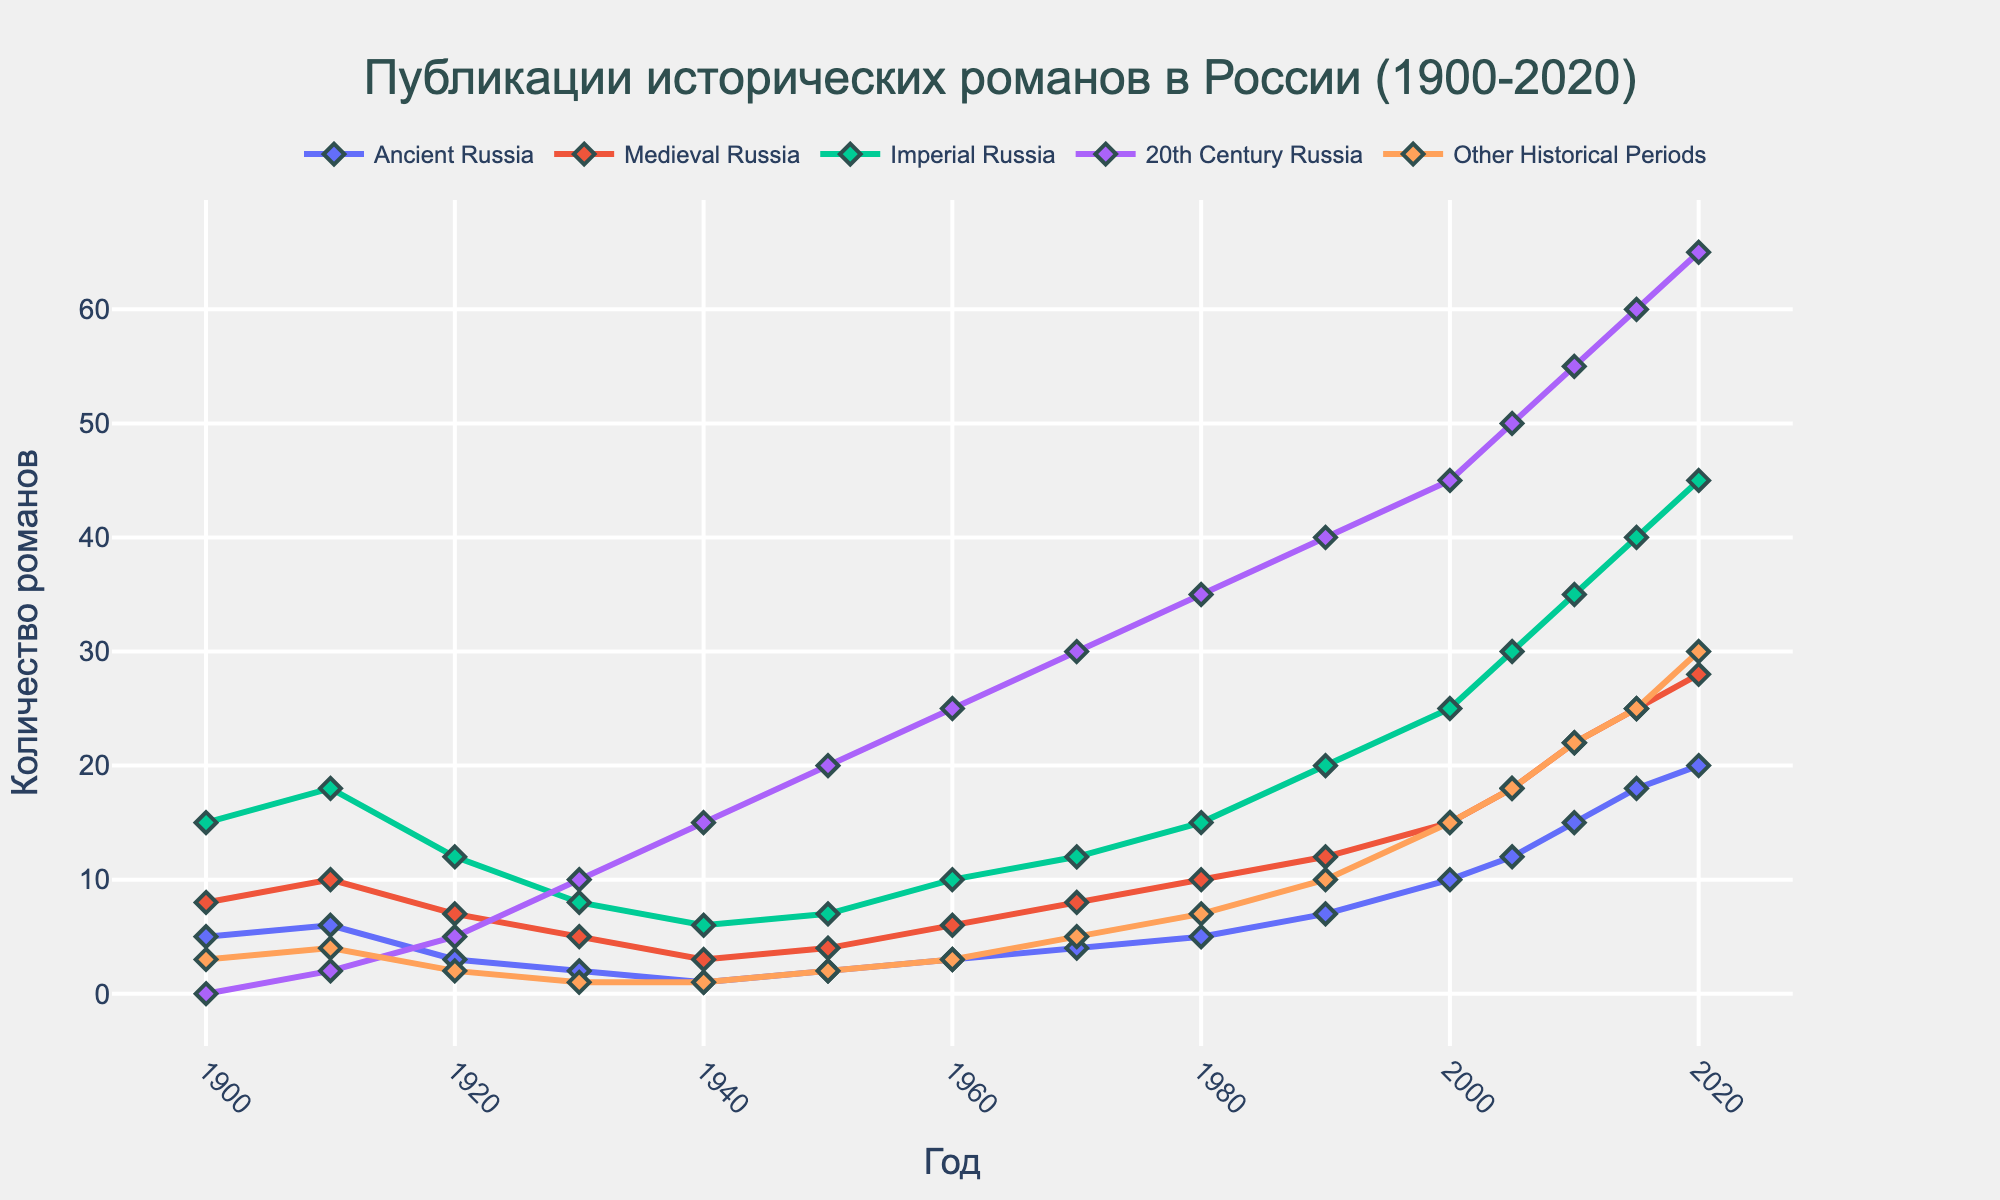How has the number of historical fiction novels set in 20th Century Russia changed from 1900 to 2020? The visual trend shows a continuous increment. In 1900, there were 0 novels, which increased to 65 by 2020.
Answer: Increased by 65 Which historical period had the highest number of publications in 2020? By observing the lines and their heights in 2020, 20th Century Russia had the highest number of novels, reaching 65.
Answer: 20th Century Russia Between 1950 and 1970, how many total historical fiction novels were published set in Medieval Russia? Sum the counts for 1950, 1960, and 1970 for Medieval Russia (4 + 6 + 8). 4 + 6 + 8 = 18
Answer: 18 What is the difference in the number of novels set in Imperial Russia between 1910 and 2010? The number in 1910 was 18 and in 2010 it was 35. The difference is calculated as 35 - 18.
Answer: 17 Which historical periods saw a decrease in the number of publications between 1910 and 1920? By looking at the heights, Ancient Russia decreased from 6 to 3, Medieval Russia from 10 to 7, Imperial Russia from 18 to 12, Other Historical Periods from 4 to 2.
Answer: Ancient Russia, Medieval Russia, Imperial Russia, Other Historical Periods Compare the publication trends for Ancient Russia and Other Historical Periods from 1900 to 2020. Ancient Russia increased from 5 to 20, while Other Historical Periods increased from 3 to 30. Both lines show an upward trend, but Other Historical Periods had a steeper increase.
Answer: Both increased, steeper for Other Historical Periods In which decade did the publications for 20th Century Russia start surpassing 10? Observe the decade when the publication count for 20th Century Russia crosses 10. It was in the 1930s when it reached 15.
Answer: 1930s What was the average number of Imperial Russia novels published per decade from 1900 to 2000? Sum the counts for every decade from 1900 to 2000 (15 + 18 + 12 + 8 + 6 + 7 + 10 + 12 + 15 + 20 + 25) and then divide by the number of decades (11). (15+18+12+8+6+7+10+12+15+20+25)/11 = 13.3636
Answer: ~13 Which three historical periods had the greatest increase in number of publications from 1950 to 2020? Calculate the increase for each period: Ancient Russia (20-2=18), Medieval Russia (28-4=24), Imperial Russia (45-7=38), 20th Century Russia (65-20=45), Other Historical Periods (30-2=28). The three greatest increases are in 20th Century Russia, Imperial Russia, and Other Historical Periods.
Answer: 20th Century Russia, Imperial Russia, Other Historical Periods 